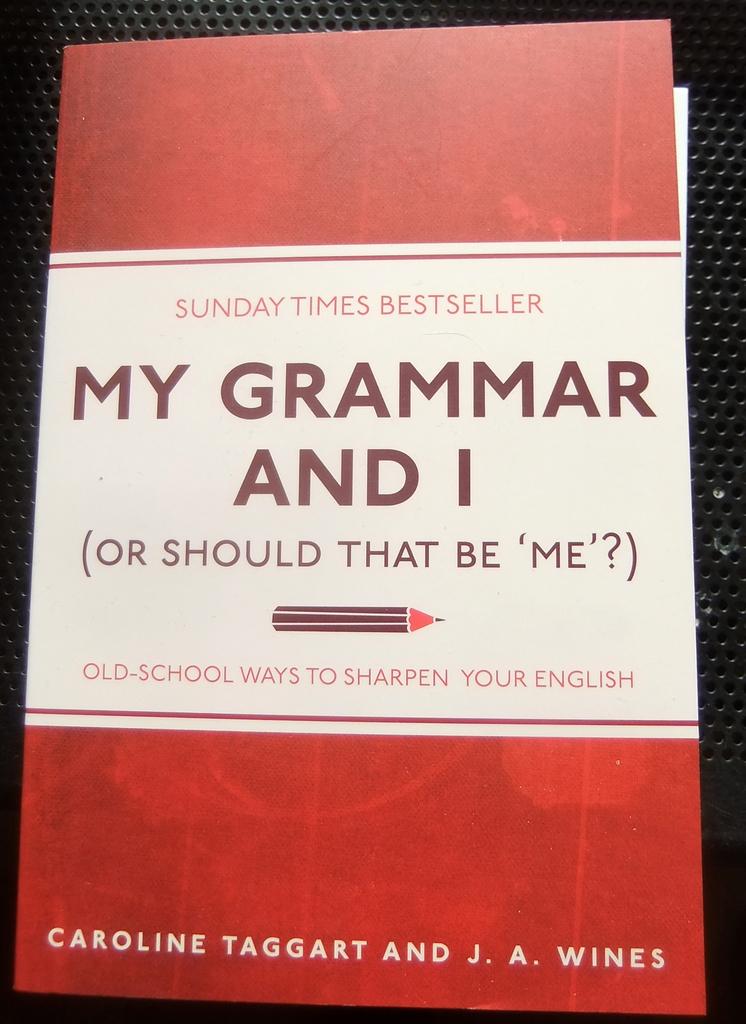What kind of ways to sharpen your english are in this book?
Keep it short and to the point. Old-school. 